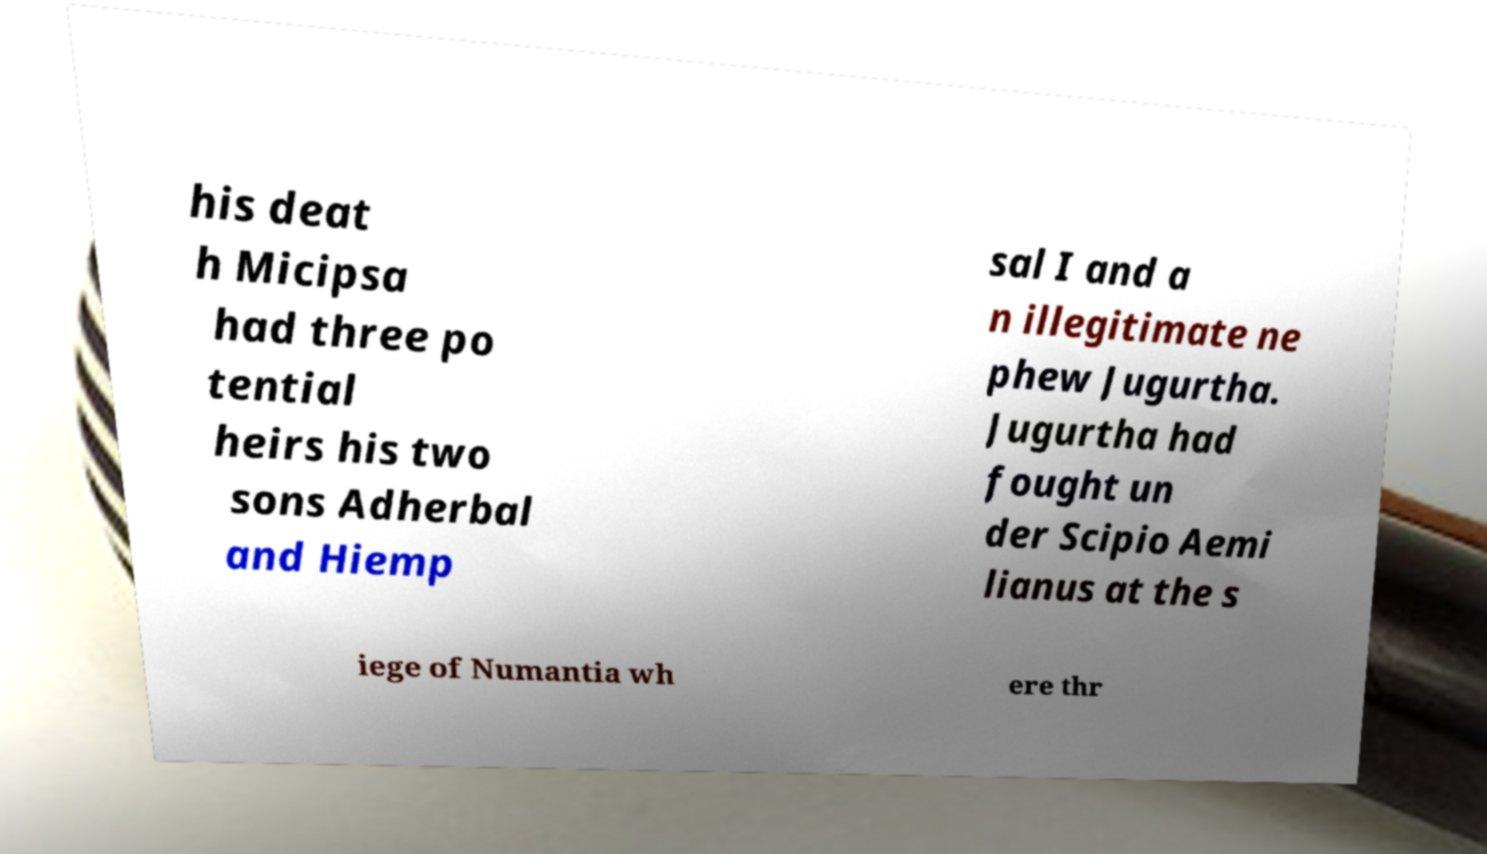Please identify and transcribe the text found in this image. his deat h Micipsa had three po tential heirs his two sons Adherbal and Hiemp sal I and a n illegitimate ne phew Jugurtha. Jugurtha had fought un der Scipio Aemi lianus at the s iege of Numantia wh ere thr 